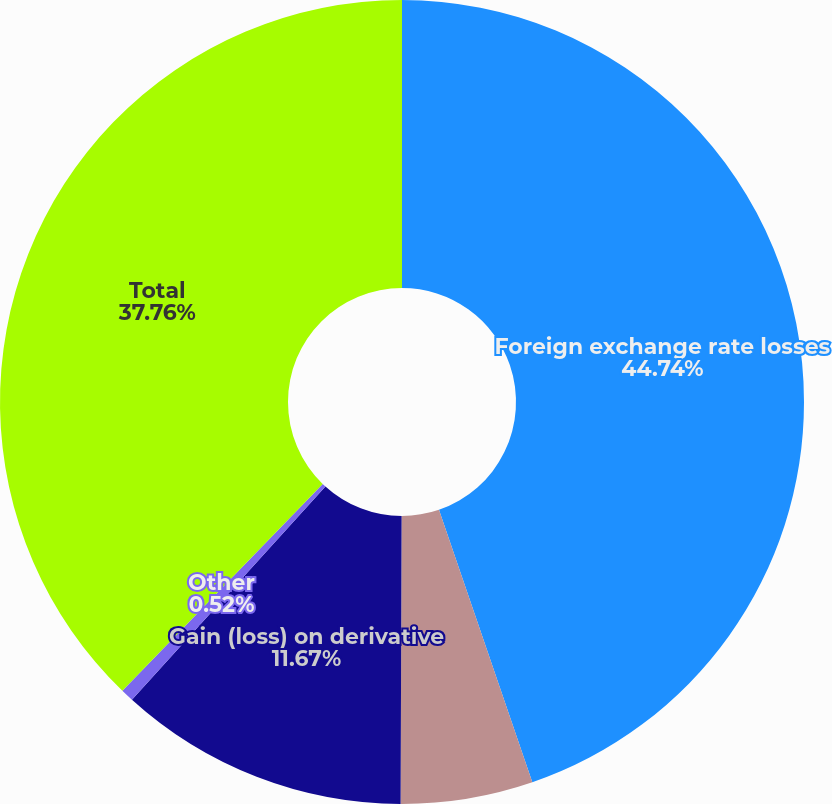<chart> <loc_0><loc_0><loc_500><loc_500><pie_chart><fcel>Foreign exchange rate losses<fcel>Equity gain (loss) of<fcel>Gain (loss) on derivative<fcel>Other<fcel>Total<nl><fcel>44.75%<fcel>5.31%<fcel>11.67%<fcel>0.52%<fcel>37.76%<nl></chart> 